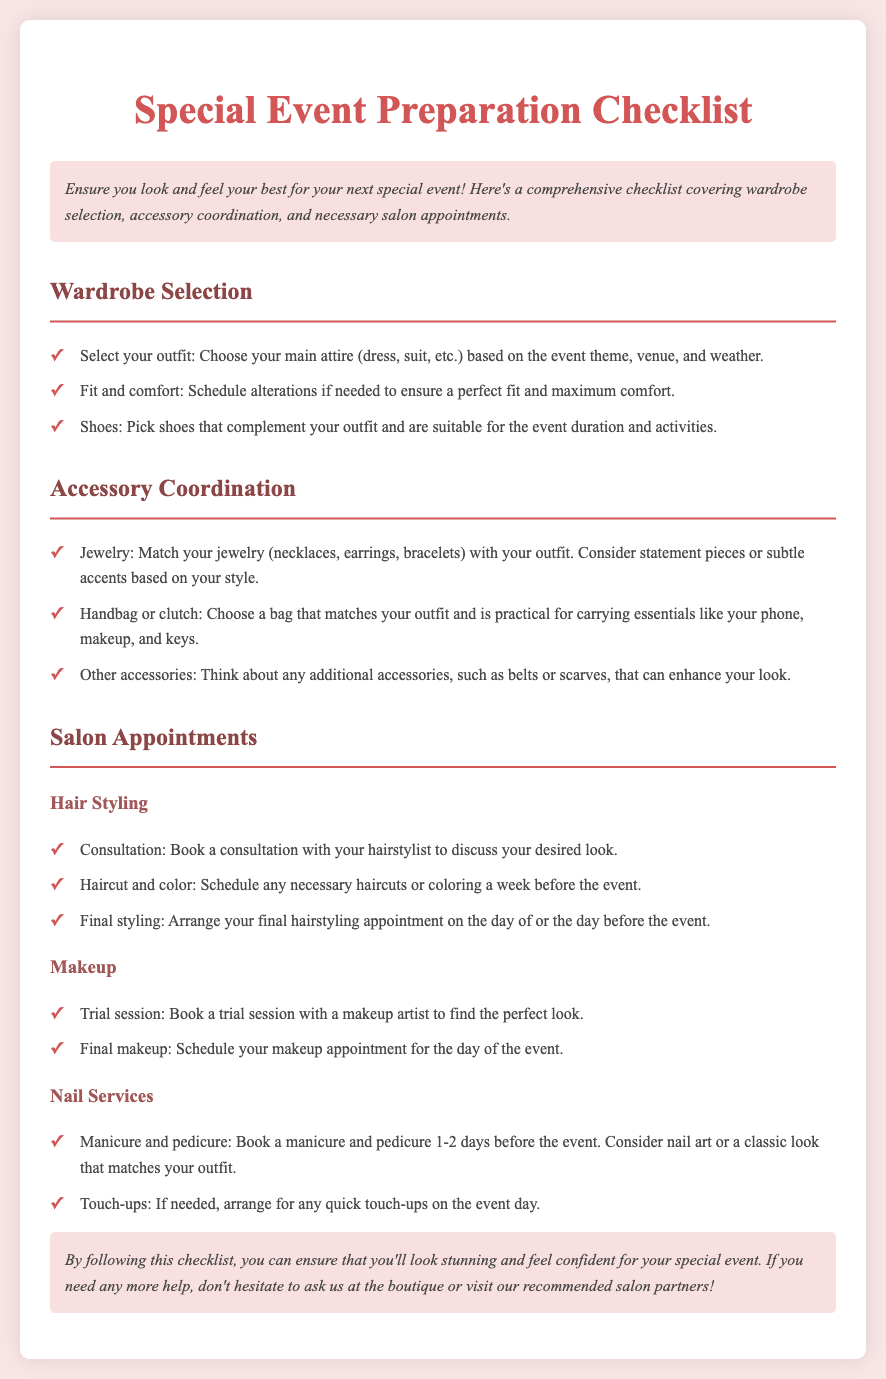what is the title of the document? The title appears prominently at the top of the document, stating the purpose of the content.
Answer: Special Event Preparation Checklist what should you consider when selecting your outfit? This detail encompasses factors that influence outfit choice based on the event context.
Answer: Event theme, venue, and weather when should you schedule alterations? The document specifies the timing related to ensuring a proper fit for your outfit.
Answer: If needed how many days before the event should you book a manicure and pedicure? This specifies the recommended timing for these beauty services in relation to the event.
Answer: 1-2 days what should you do during your hair consultation? This question relates to the purpose of a specific salon appointment mentioned in the text.
Answer: Discuss your desired look how can jewelry be chosen for the event? This requires reasoning about accessory coordination as mentioned in the checklist.
Answer: Match with your outfit what is suggested to carry your essentials to the event? This question focuses on the types of bags recommended based on the document's information.
Answer: Handbag or clutch when should the final hairstyling appointment be arranged? This question pertains to the timing of the last hair service before the event.
Answer: The day of or the day before the event what is the final step in preparing for makeup services? This details the scheduling aspect of makeup services leading up to the event.
Answer: Schedule your makeup appointment for the day of the event 